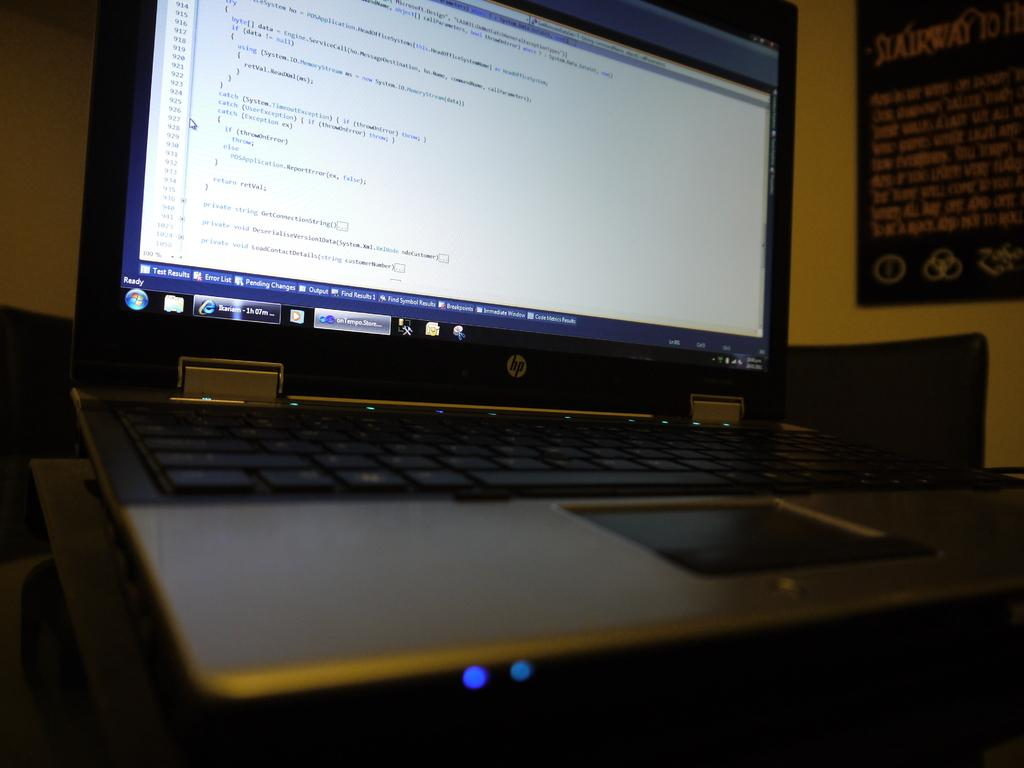What electronic device is in the foreground of the image? There is a laptop in the foreground of the image. What color is the wall visible in the background? The wall in the background is yellow. What is hanging on the wall in the image? There is a paper poster on the wall. What type of liquid can be seen dripping from the carpenter's tool in the image? There is no carpenter or tool present in the image, and therefore no liquid can be seen dripping. 